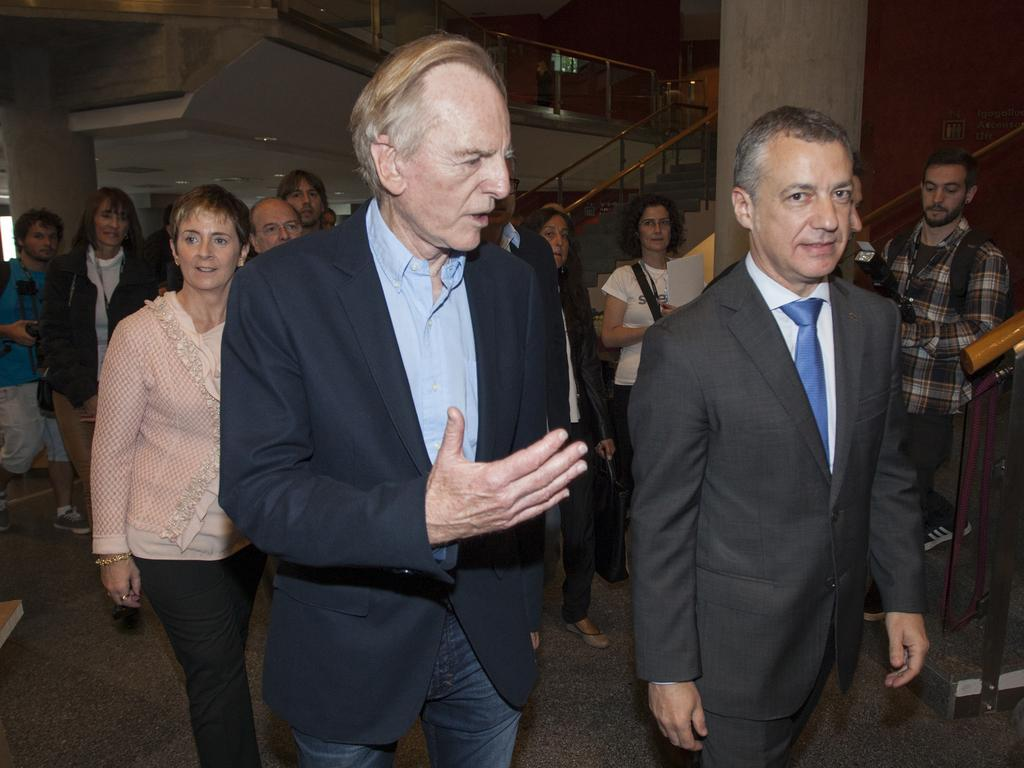What can be seen in the image involving people? There are people standing in the image. Where are the people standing? The people are standing on the floor. What architectural feature is present in the image? There are stairs in the image. What safety feature is present in the image? There is a railing in the image. What structural elements can be seen in the image? There are pillars in the image. What type of farm can be seen in the image? There is no farm present in the image. What nation is depicted in the image? The image does not depict a specific nation. 